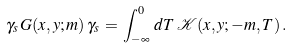Convert formula to latex. <formula><loc_0><loc_0><loc_500><loc_500>\gamma _ { s } \, G ( x , y ; m ) \, \gamma _ { s } \, = \, \int _ { - \infty } ^ { 0 } \, d T \, { \mathcal { K } } ( x , y ; - m , T ) \, .</formula> 